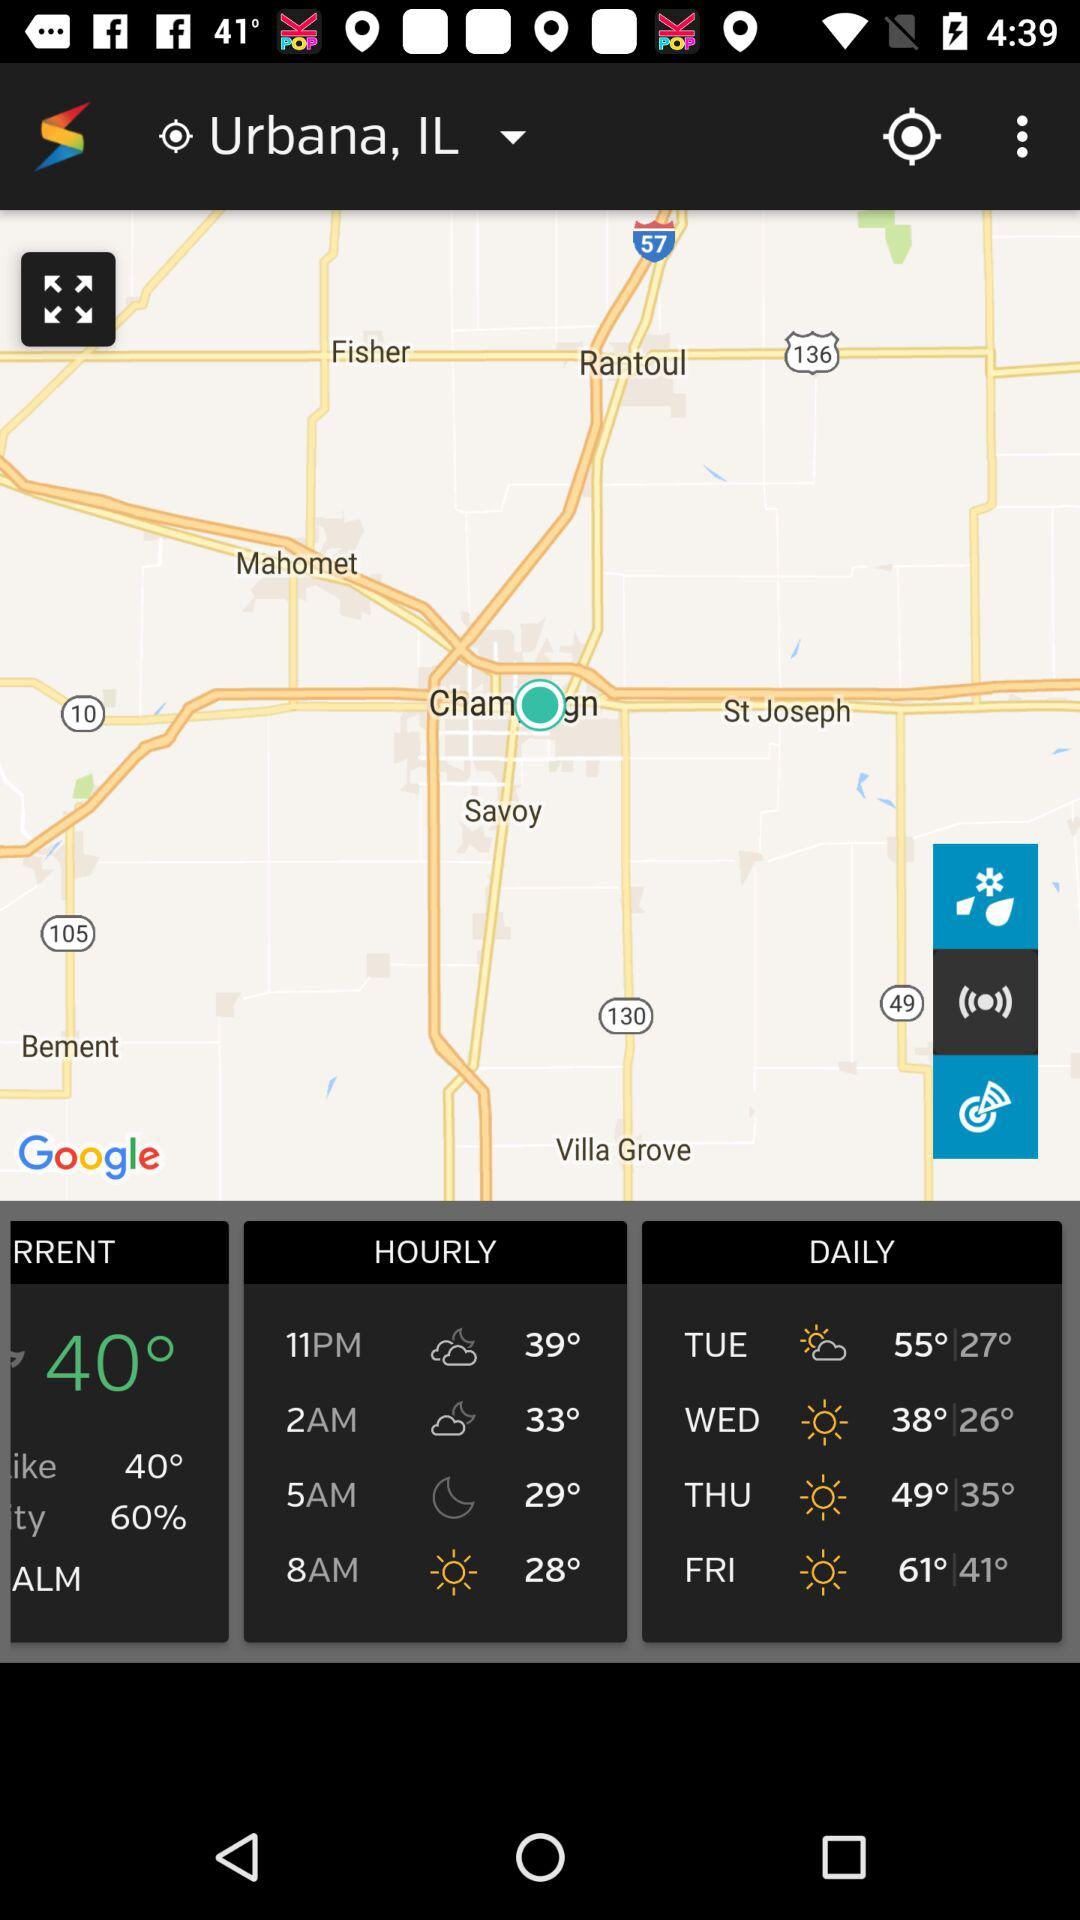What is the weather at 11 pm?
When the provided information is insufficient, respond with <no answer>. <no answer> 